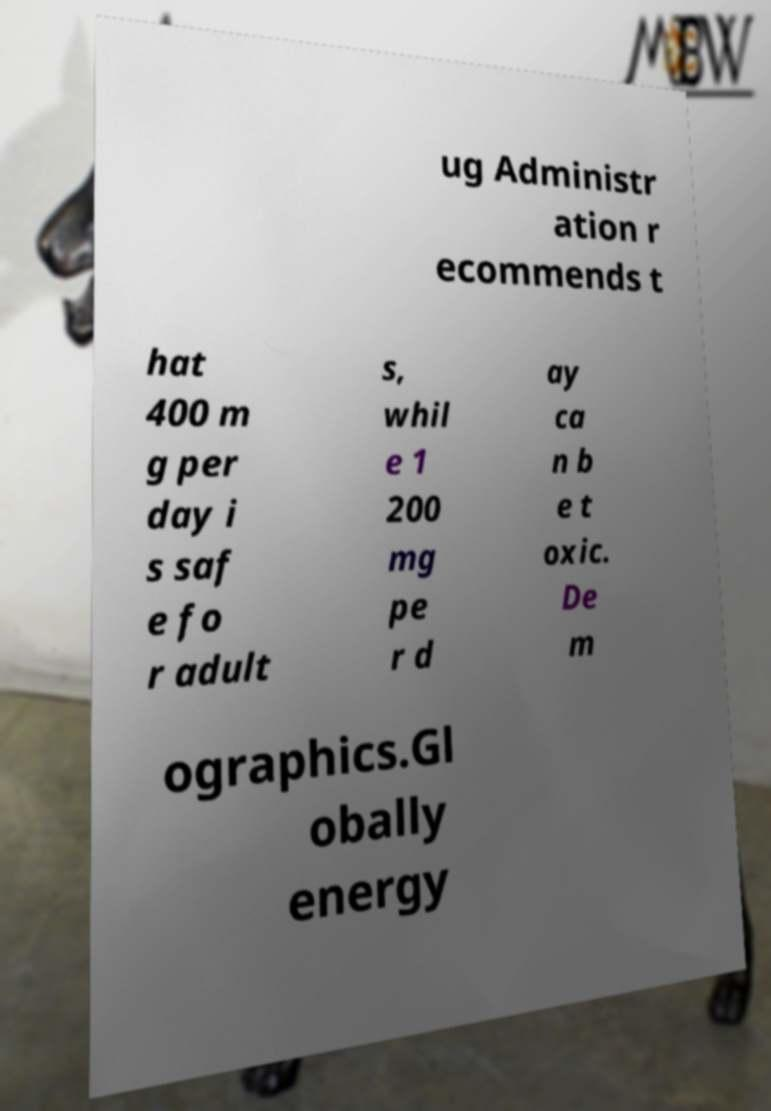Can you read and provide the text displayed in the image?This photo seems to have some interesting text. Can you extract and type it out for me? ug Administr ation r ecommends t hat 400 m g per day i s saf e fo r adult s, whil e 1 200 mg pe r d ay ca n b e t oxic. De m ographics.Gl obally energy 